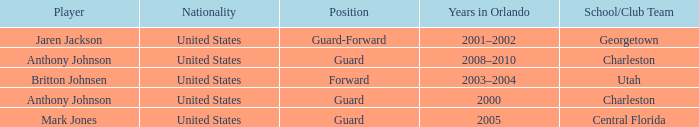Who was the Player that spent the Year 2005 in Orlando? Mark Jones. 